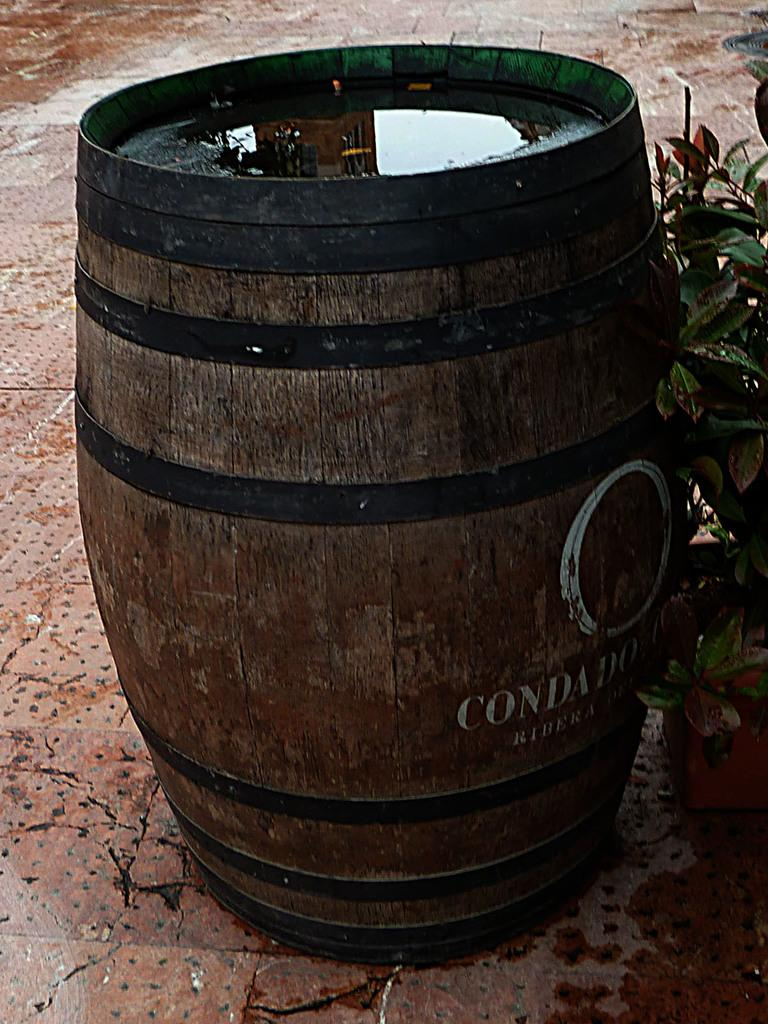<image>
Relay a brief, clear account of the picture shown. A Condado barrel filled with water is sitting on the rainy sidewalk. 